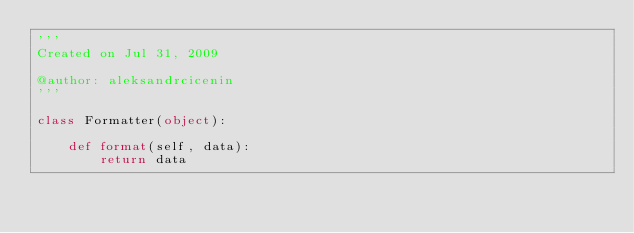Convert code to text. <code><loc_0><loc_0><loc_500><loc_500><_Python_>'''
Created on Jul 31, 2009

@author: aleksandrcicenin
'''

class Formatter(object):

    def format(self, data):
        return data
</code> 